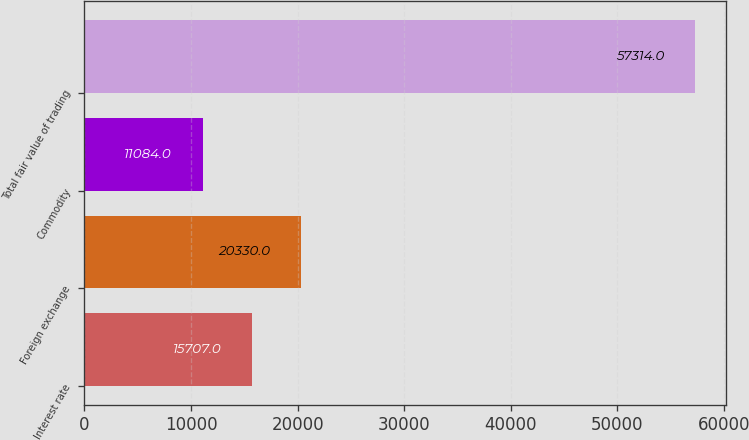Convert chart to OTSL. <chart><loc_0><loc_0><loc_500><loc_500><bar_chart><fcel>Interest rate<fcel>Foreign exchange<fcel>Commodity<fcel>Total fair value of trading<nl><fcel>15707<fcel>20330<fcel>11084<fcel>57314<nl></chart> 